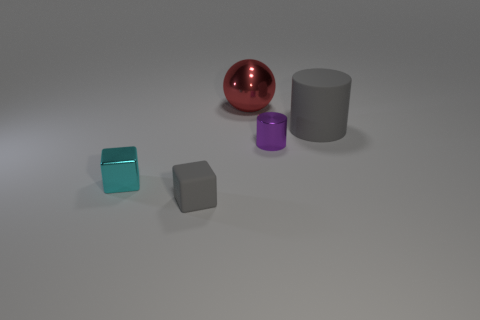What number of things are either objects that are to the left of the small matte thing or small shiny things to the left of the red metal sphere?
Your response must be concise. 1. What material is the cube that is the same size as the cyan metallic object?
Your answer should be very brief. Rubber. How many other objects are the same material as the red ball?
Provide a succinct answer. 2. There is a gray thing that is on the right side of the tiny gray matte cube; is it the same shape as the tiny thing right of the tiny gray thing?
Your response must be concise. Yes. There is a metallic thing right of the large object that is left of the gray cylinder right of the gray block; what is its color?
Provide a succinct answer. Purple. How many other things are there of the same color as the tiny cylinder?
Provide a succinct answer. 0. Are there fewer small blue cylinders than large rubber objects?
Your response must be concise. Yes. What is the color of the metallic thing that is left of the shiny cylinder and in front of the big gray object?
Your response must be concise. Cyan. There is a tiny gray thing that is the same shape as the tiny cyan object; what is its material?
Make the answer very short. Rubber. Are there any other things that are the same size as the rubber cube?
Give a very brief answer. Yes. 